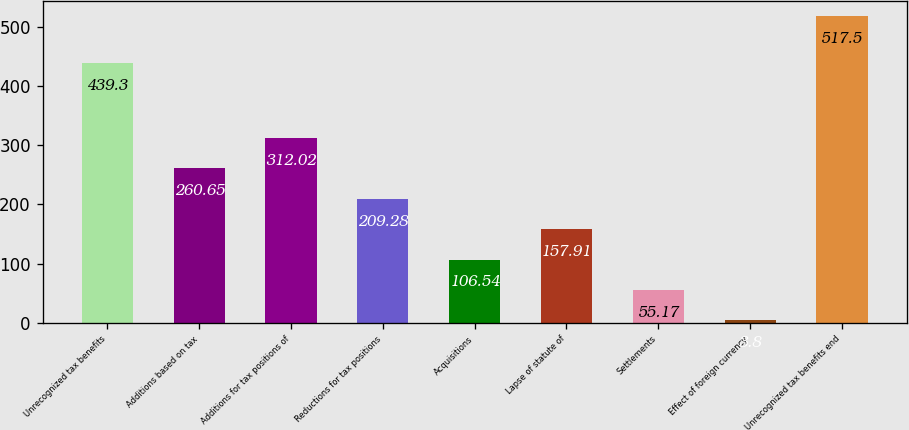Convert chart to OTSL. <chart><loc_0><loc_0><loc_500><loc_500><bar_chart><fcel>Unrecognized tax benefits<fcel>Additions based on tax<fcel>Additions for tax positions of<fcel>Reductions for tax positions<fcel>Acquisitions<fcel>Lapse of statute of<fcel>Settlements<fcel>Effect of foreign currency<fcel>Unrecognized tax benefits end<nl><fcel>439.3<fcel>260.65<fcel>312.02<fcel>209.28<fcel>106.54<fcel>157.91<fcel>55.17<fcel>3.8<fcel>517.5<nl></chart> 